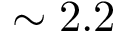Convert formula to latex. <formula><loc_0><loc_0><loc_500><loc_500>\sim 2 . 2</formula> 